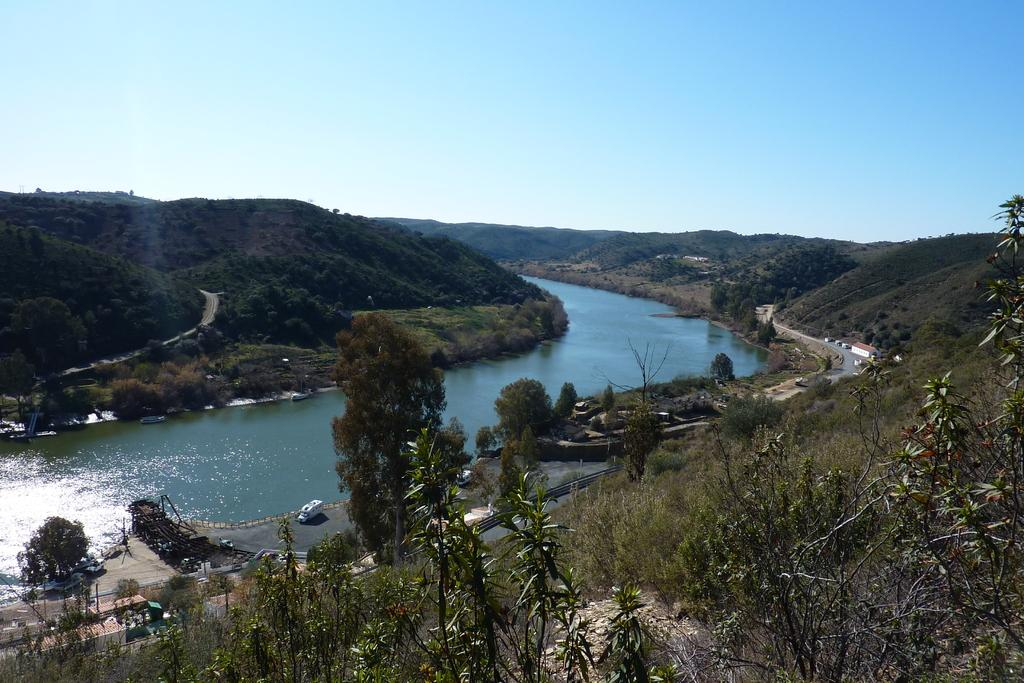What type of natural feature can be seen in the image? There is a lake in the image. What is happening on the road in the image? Vehicles are moving on the road in the image. What type of vegetation is visible in the image? Trees are visible in the image. What type of geographical feature can be seen in the image? Hills are present in the image. How many cacti are growing near the lake in the image? There are no cacti visible in the image; only trees are present. What type of metal is being used to construct the vehicles in the image? The type of metal used to construct the vehicles is not visible in the image, but it is common for vehicles to be made of iron or steel. 